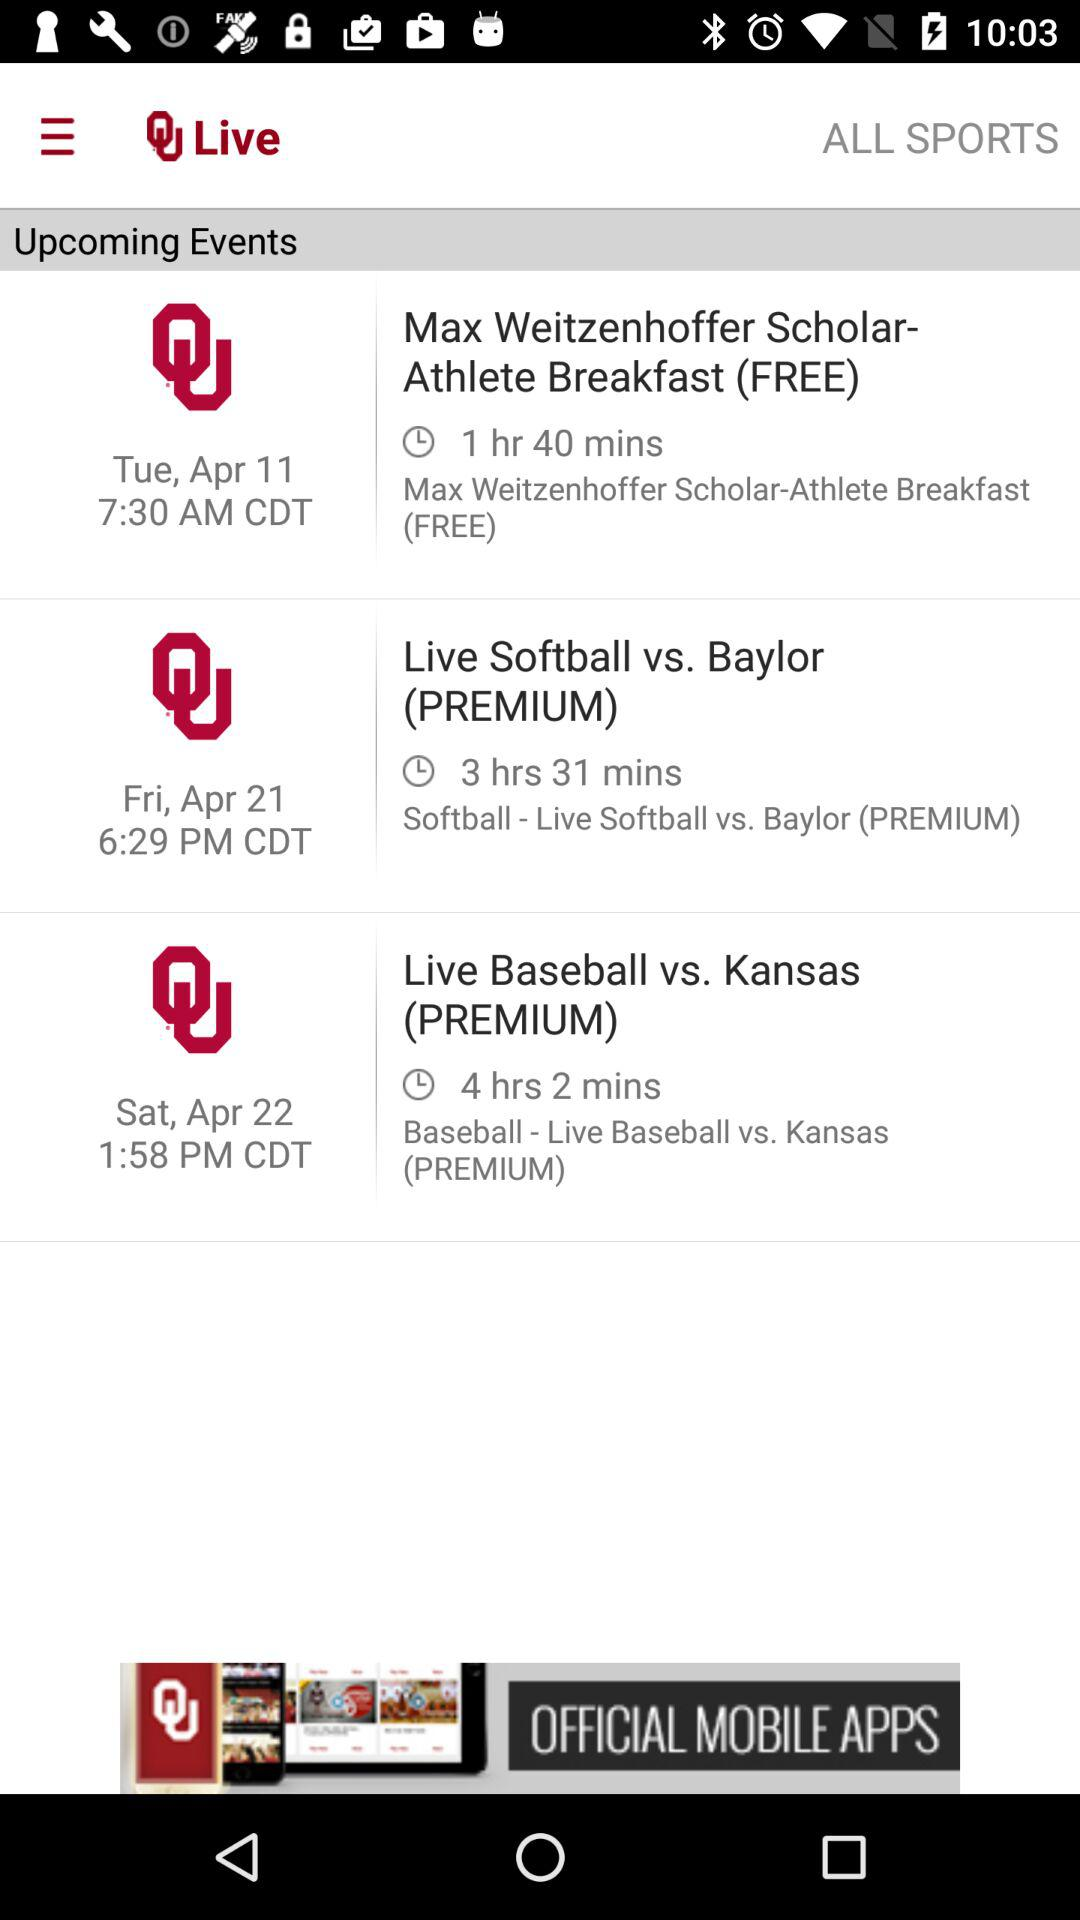What is the starting time for the live event of "Softball vs. Baylor (PREMIUM)"? The starting time is 6:29 PM. 